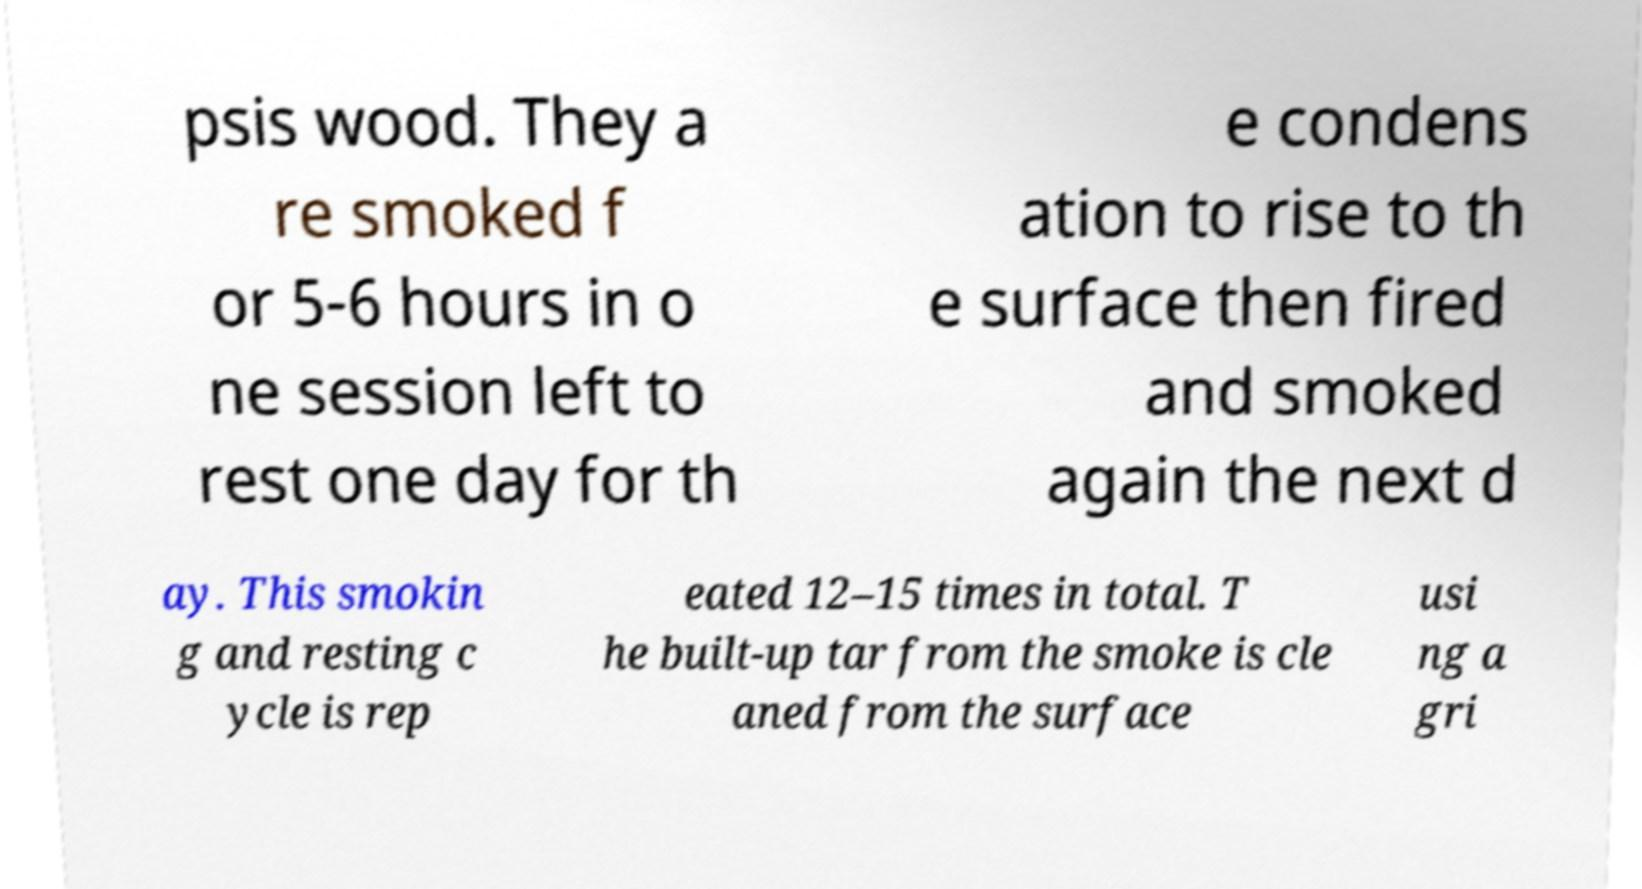Could you assist in decoding the text presented in this image and type it out clearly? psis wood. They a re smoked f or 5-6 hours in o ne session left to rest one day for th e condens ation to rise to th e surface then fired and smoked again the next d ay. This smokin g and resting c ycle is rep eated 12–15 times in total. T he built-up tar from the smoke is cle aned from the surface usi ng a gri 